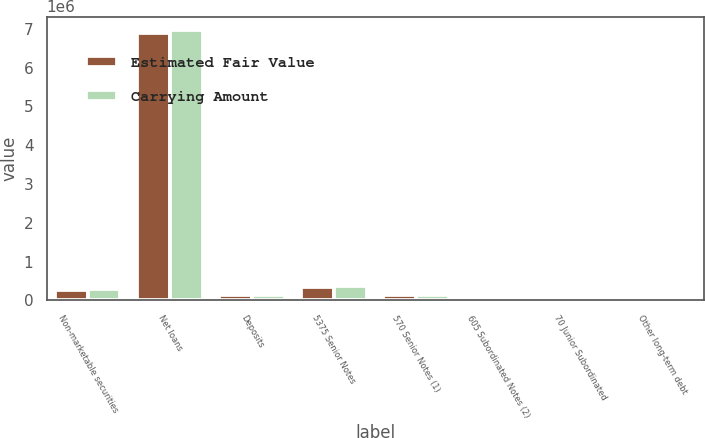<chart> <loc_0><loc_0><loc_500><loc_500><stacked_bar_chart><ecel><fcel>Non-marketable securities<fcel>Net loans<fcel>Deposits<fcel>5375 Senior Notes<fcel>570 Senior Notes (1)<fcel>605 Subordinated Notes (2)<fcel>70 Junior Subordinated<fcel>Other long-term debt<nl><fcel>Estimated Fair Value<fcel>267508<fcel>6.88014e+06<fcel>144576<fcel>347793<fcel>143969<fcel>55075<fcel>55372<fcel>1439<nl><fcel>Carrying Amount<fcel>290393<fcel>6.96444e+06<fcel>144576<fcel>362786<fcel>145184<fcel>57746<fcel>51526<fcel>1439<nl></chart> 